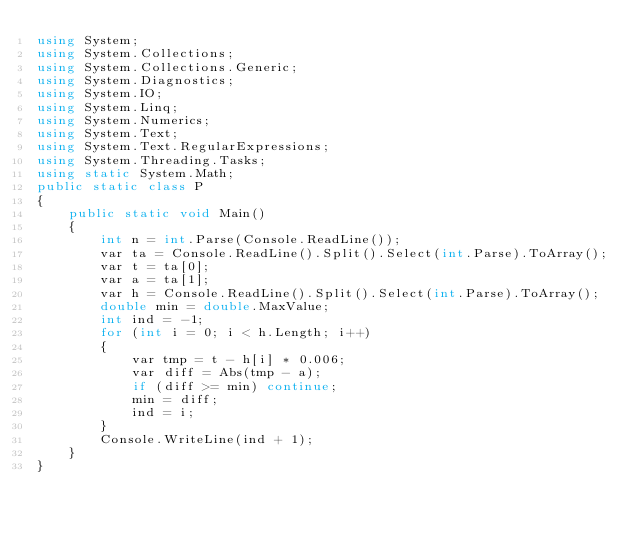Convert code to text. <code><loc_0><loc_0><loc_500><loc_500><_C#_>using System;
using System.Collections;
using System.Collections.Generic;
using System.Diagnostics;
using System.IO;
using System.Linq;
using System.Numerics;
using System.Text;
using System.Text.RegularExpressions;
using System.Threading.Tasks;
using static System.Math;
public static class P
{
    public static void Main()
    {
        int n = int.Parse(Console.ReadLine());
        var ta = Console.ReadLine().Split().Select(int.Parse).ToArray();
        var t = ta[0];
        var a = ta[1];
        var h = Console.ReadLine().Split().Select(int.Parse).ToArray();
        double min = double.MaxValue;
        int ind = -1;
        for (int i = 0; i < h.Length; i++)
        {
            var tmp = t - h[i] * 0.006;
            var diff = Abs(tmp - a);
            if (diff >= min) continue;
            min = diff;
            ind = i;
        }
        Console.WriteLine(ind + 1);
    }
}</code> 